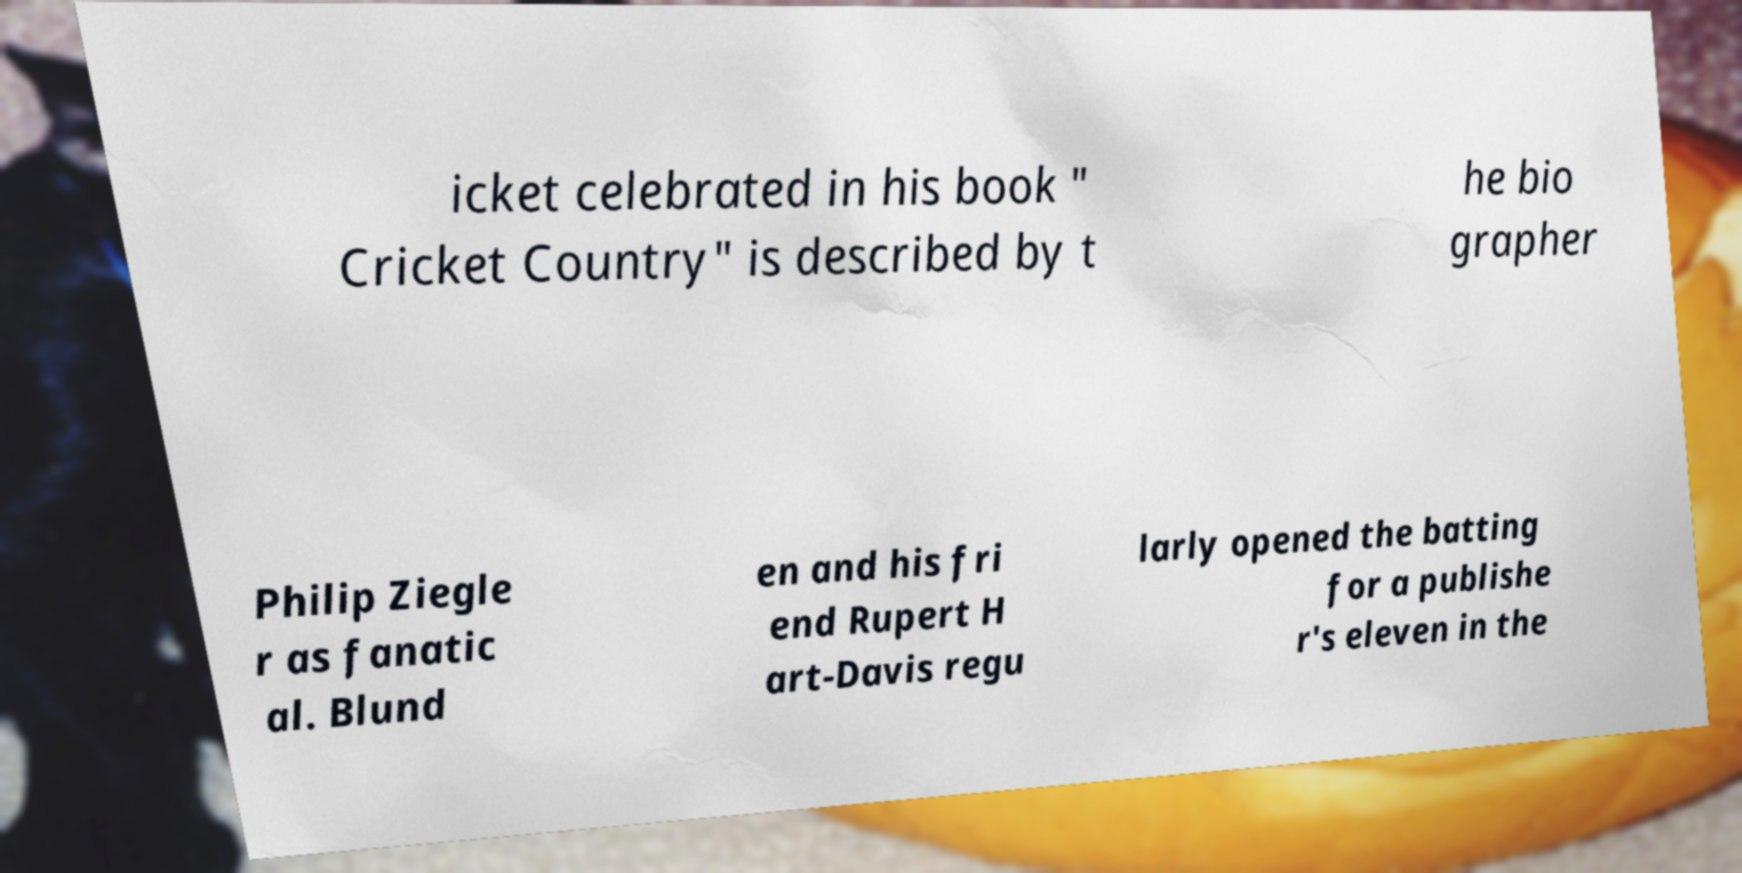Could you assist in decoding the text presented in this image and type it out clearly? icket celebrated in his book " Cricket Country" is described by t he bio grapher Philip Ziegle r as fanatic al. Blund en and his fri end Rupert H art-Davis regu larly opened the batting for a publishe r's eleven in the 